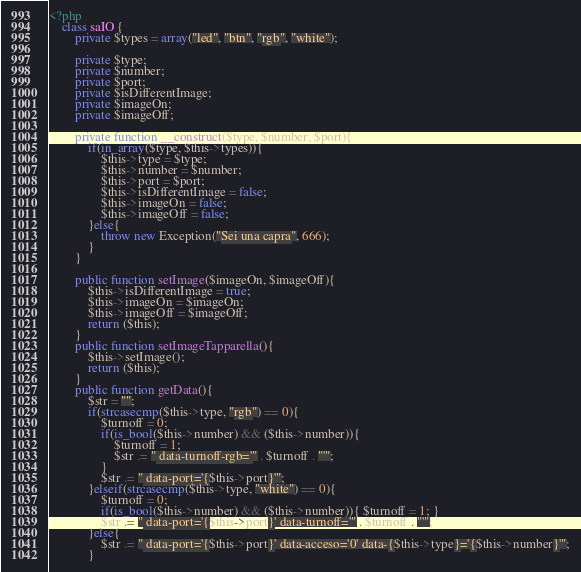Convert code to text. <code><loc_0><loc_0><loc_500><loc_500><_PHP_><?php
    class saIO {
        private $types = array("led", "btn", "rgb", "white");
        
        private $type;
        private $number;
        private $port;
        private $isDifferentImage;
        private $imageOn;
        private $imageOff;
        
        private function __construct($type, $number, $port){
            if(in_array($type, $this->types)){
                $this->type = $type;
                $this->number = $number;
                $this->port = $port;
                $this->isDifferentImage = false;
                $this->imageOn = false;
                $this->imageOff = false;
            }else{
                throw new Exception("Sei una capra", 666);
            }
        }
        
        public function setImage($imageOn, $imageOff){
            $this->isDifferentImage = true;
            $this->imageOn = $imageOn;
            $this->imageOff = $imageOff;
            return ($this);
        }
        public function setImageTapparella(){
            $this->setImage();
            return ($this);
        }
        public function getData(){
            $str = "";
            if(strcasecmp($this->type, "rgb") == 0){
                $turnoff = 0;
                if(is_bool($this->number) && ($this->number)){
                    $turnoff = 1;
                    $str .= " data-turnoff-rgb='" . $turnoff . "'";
                }
                $str .= " data-port='{$this->port}'";
            }elseif(strcasecmp($this->type, "white") == 0){
                $turnoff = 0;
                if(is_bool($this->number) && ($this->number)){ $turnoff = 1; }
                $str .= " data-port='{$this->port}' data-turnoff='" . $turnoff . "'";
            }else{
                $str .= " data-port='{$this->port}' data-acceso='0' data-{$this->type}='{$this->number}'";
            }</code> 